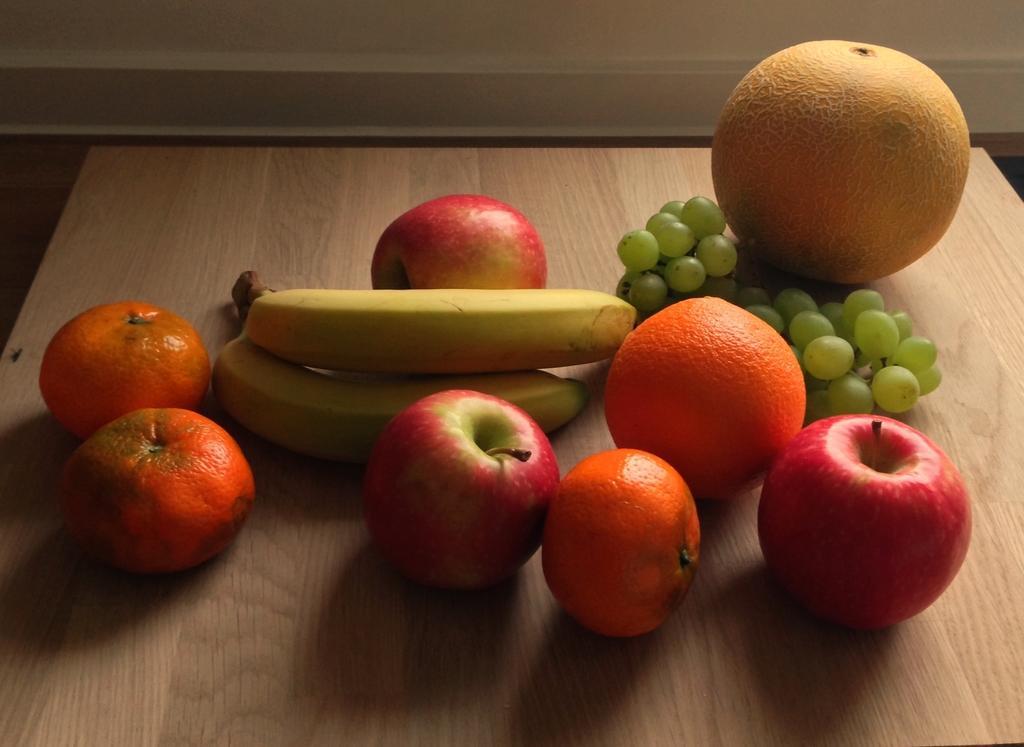Can you describe this image briefly? In this image we can see some fruits on the table, some of them are apples, oranges, bananas and grapes. 